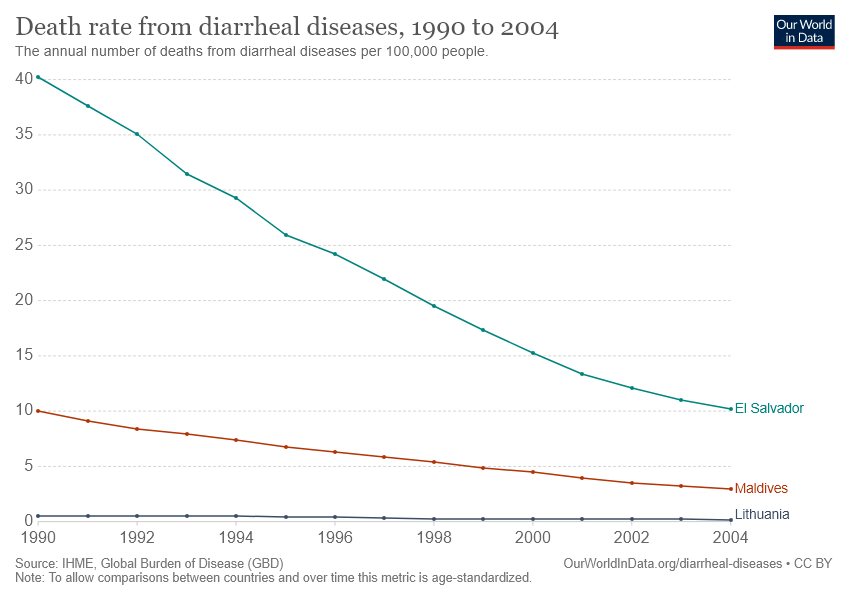List a handful of essential elements in this visual. Dividing El Salvador's last data with Maldives' first data results in a value of 0.02228320508685239. Red line data country" refers to the country of Maldives. 